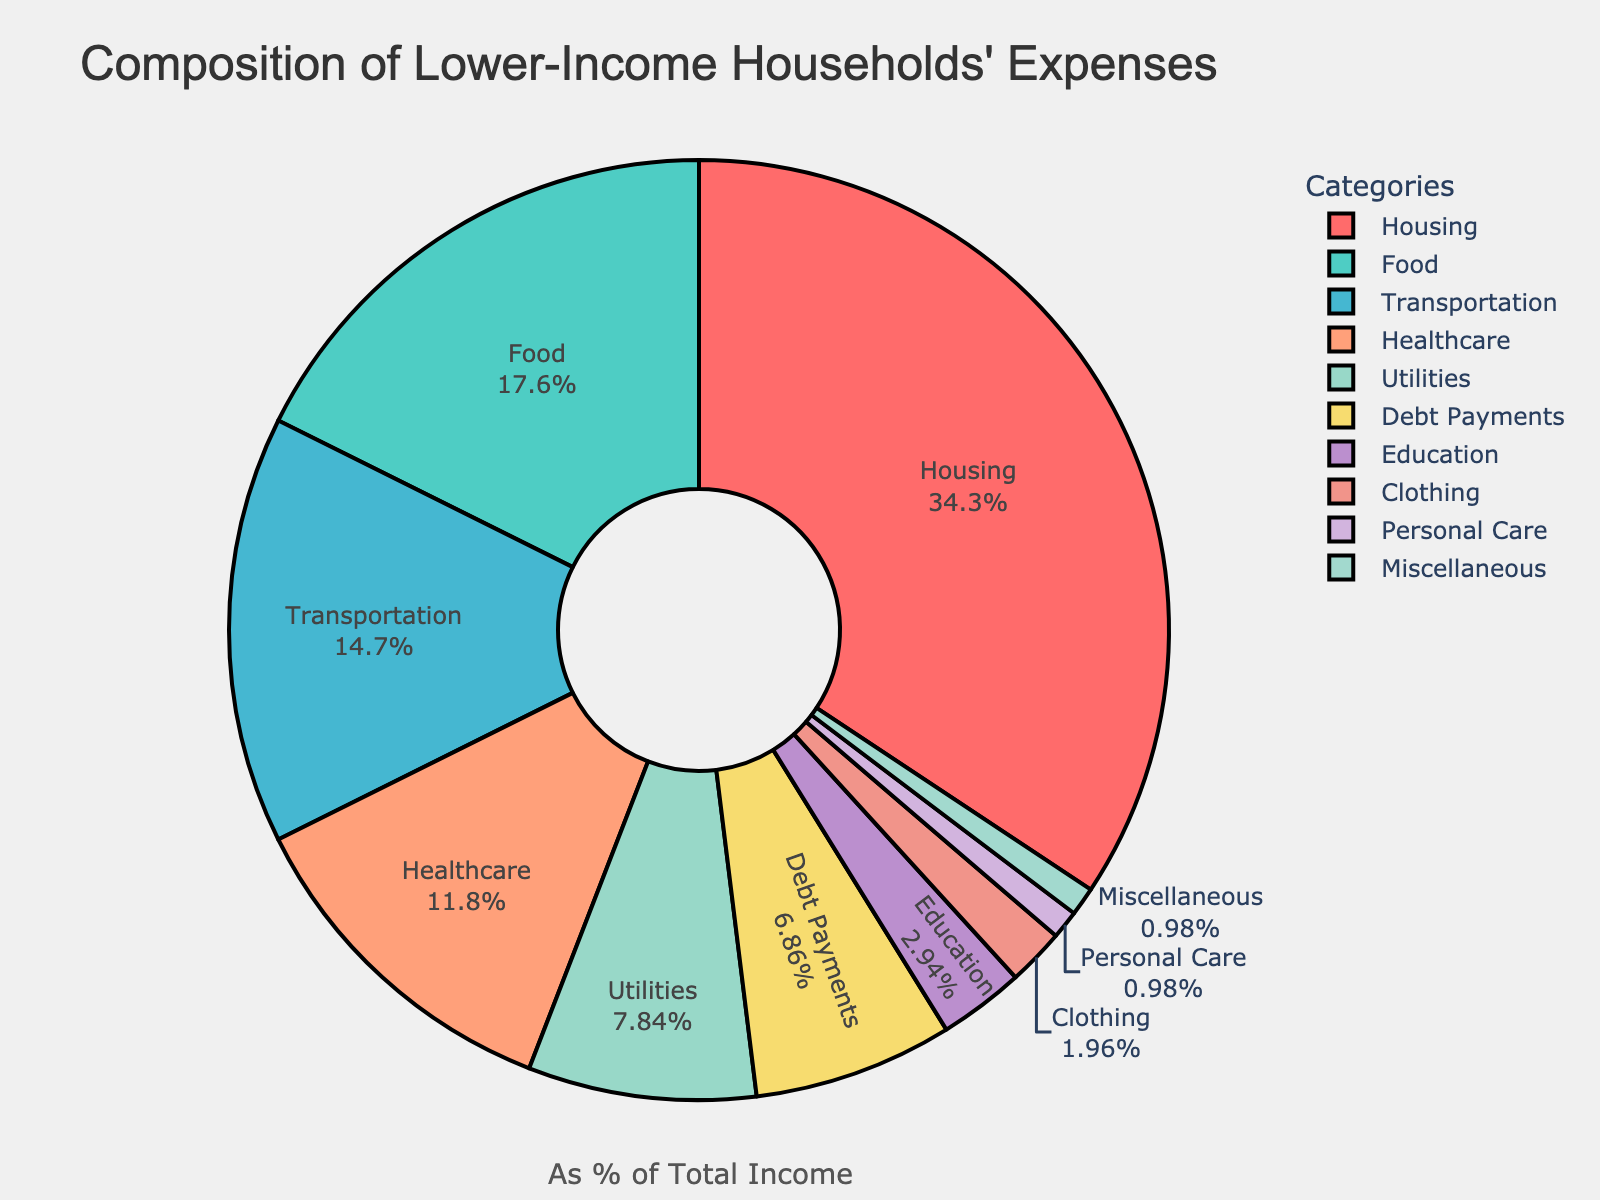What's the largest expense category for lower-income households? The largest expense category in the figure is the one with the largest percentage. In this case, the category with the highest percentage is Housing, which is 35%.
Answer: Housing Which two categories have a combined expense of more than 50% of the total income? To determine this, add the percentages of the categories in pairs and find those that exceed 50%. Housing (35%) + Food (18%) = 53%, which exceeds 50%.
Answer: Housing and Food How much more do lower-income households spend on Transportation compared to Education? Subtract the percentage spent on Education from the percentage spent on Transportation. Transportation is 15% and Education is 3%. So, 15% - 3% = 12%.
Answer: 12% Is the percentage spent on Healthcare greater than the percentage spent on Utilities and Debt Payments combined? Add the percentages of Utilities (8%) and Debt Payments (7%), which equals 15%. Compare this with the percentage for Healthcare, which is 12%. Since 12% is less than 15%, no.
Answer: No Which expense category is represented by the yellow (or gold) slice in the figure? The slice colored in yellow (or gold) represents a category. By identifying the yellow (or gold) slice in the figure and referring to the legend, it is Debt Payments.
Answer: Debt Payments What is the total percentage of income spent on Housing, Food, and Transportation combined? Add the percentages of the three categories: Housing (35%), Food (18%), and Transportation (15%). So, 35% + 18% + 15% = 68%.
Answer: 68% What is the percentage difference between Utilities and Debt Payments? Subtract the percentage of Debt Payments (7%) from the percentage of Utilities (8%). So, 8% - 7% = 1%.
Answer: 1% Which category is the smallest in terms of percentage of total income, and how much is it? The smallest expense category is the one with the smallest percentage. According to the figure, the smallest is Personal Care and Miscellaneous each with 1%. Hence, the Personal Care or Miscellaneous category is the smallest, each at 1%.
Answer: Personal Care or Miscellaneous, 1% Rank the top three categories in terms of the percentage of total income spent. By looking at the figure and the percentages, the top three categories are Housing (35%), Food (18%), and Transportation (15%).
Answer: Housing, Food, Transportation Do lower-income households spend a higher percentage on Food or Healthcare? Compare the percentages of Food and Healthcare in the figure. Food is 18%, and Healthcare is 12%. Since 18% is greater than 12%, they spend a higher percentage on Food.
Answer: Food What is the total percentage of income spent on non-essential categories (Clothing, Personal Care, Miscellaneous)? Add the percentages of the non-essential categories: Clothing (2%), Personal Care (1%), and Miscellaneous (1%). So, 2% + 1% + 1% = 4%.
Answer: 4% 